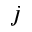<formula> <loc_0><loc_0><loc_500><loc_500>j</formula> 